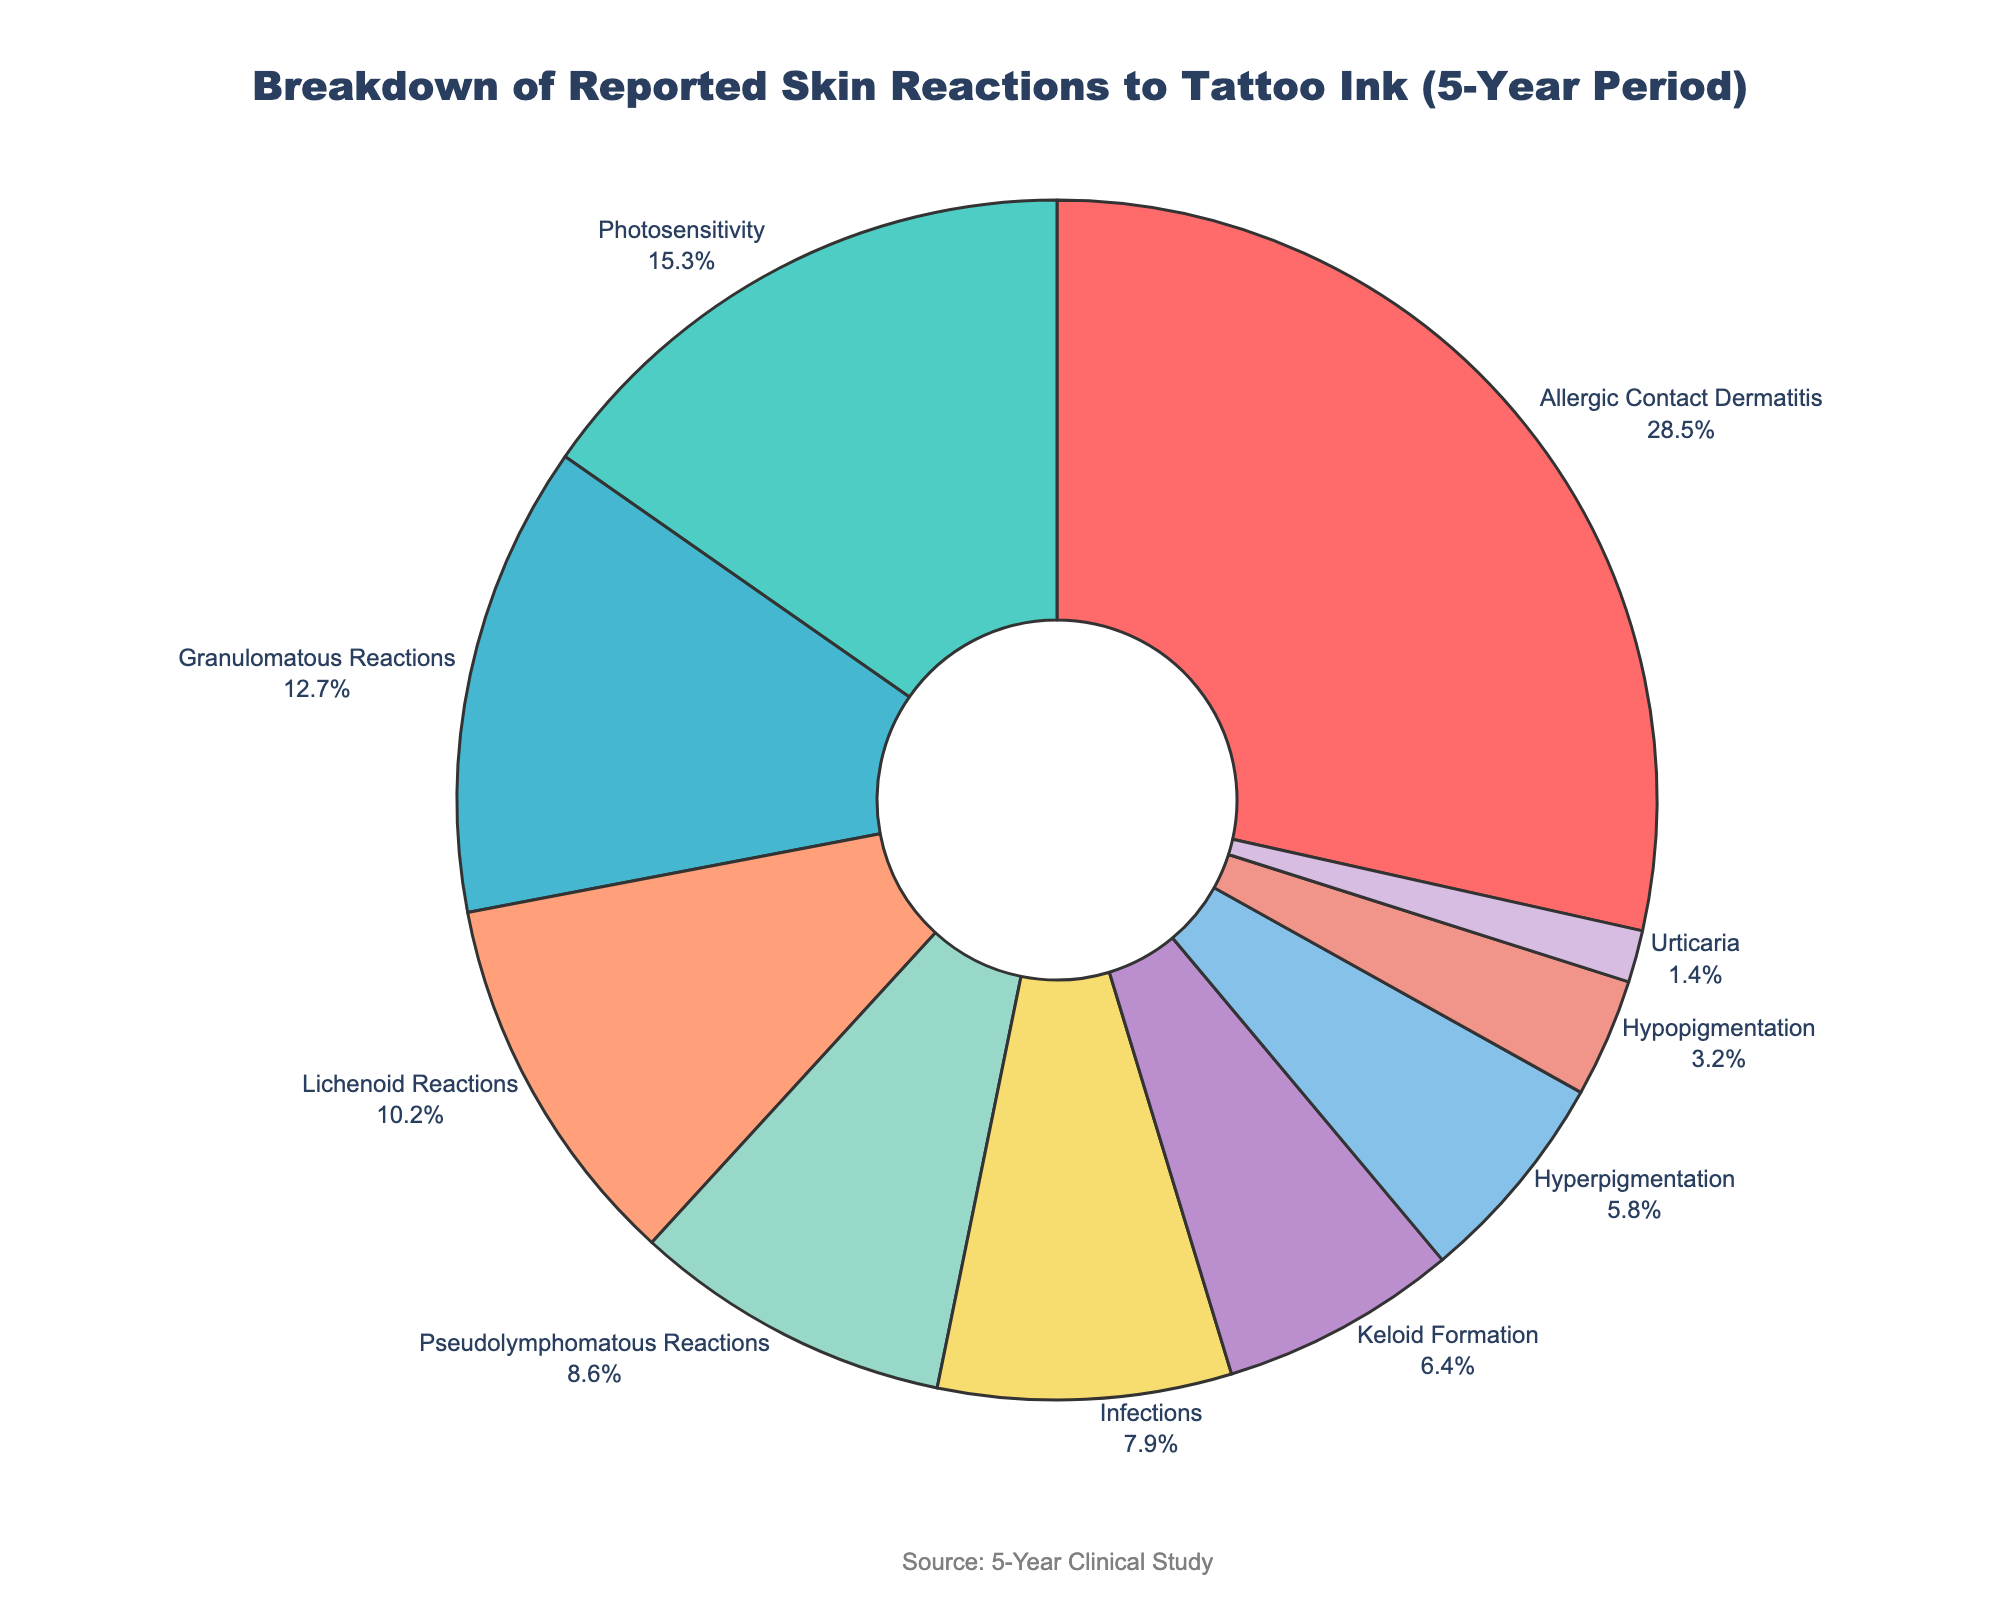What's the most common skin reaction to tattoo ink? The largest section of the pie chart is labeled "Allergic Contact Dermatitis" with 28.5%, indicating it is the most common skin reaction to tattoo ink.
Answer: Allergic Contact Dermatitis Which skin reaction has the smallest percentage? The smallest section of the pie chart is labeled "Urticaria" with 1.4%, indicating it has the smallest percentage among the reported skin reactions.
Answer: Urticaria What is the combined percentage of granulomatous reactions and lichenoid reactions? The percentages for granulomatous reactions and lichenoid reactions are 12.7% and 10.2% respectively. Adding these together gives 12.7 + 10.2 = 22.9%.
Answer: 22.9% How does the percentage of photosensitivity compare to keloid formation? Photosensitivity has a percentage of 15.3% and keloid formation has a percentage of 6.4%. Comparatively, photosensitivity is greater than keloid formation.
Answer: Photosensitivity is greater What is the total percentage of pseudolymphomatous reactions, infections, and hyperpigmentation? Summing the percentages for pseudolymphomatous reactions (8.6%), infections (7.9%), and hyperpigmentation (5.8%) gives 8.6 + 7.9 + 5.8 = 22.3%.
Answer: 22.3% Which skin reaction appears in blue color? The pie chart section in blue color is labeled "Granulomatous Reactions" as per the provided color scheme.
Answer: Granulomatous Reactions Is the percentage of hypopigmentation greater than or less than hyperpigmentation? The percentage of hypopigmentation is 3.2%, whereas hyperpigmentation is 5.8%. Hypopigmentation is less than hyperpigmentation.
Answer: Less What is the combined percentage of all skin reactions except allergic contact dermatitis? Subtracting the percentage of allergic contact dermatitis (28.5%) from 100% gives 100 - 28.5 = 71.5%.
Answer: 71.5% How does the sum of allergic contact dermatitis, photosensitivity, and granulomatous reactions compare to 50%? Summing the percentages of allergic contact dermatitis (28.5%), photosensitivity (15.3%), and granulomatous reactions (12.7%) gives 28.5 + 15.3 + 12.7 = 56.5%, which is greater than 50%.
Answer: Greater 